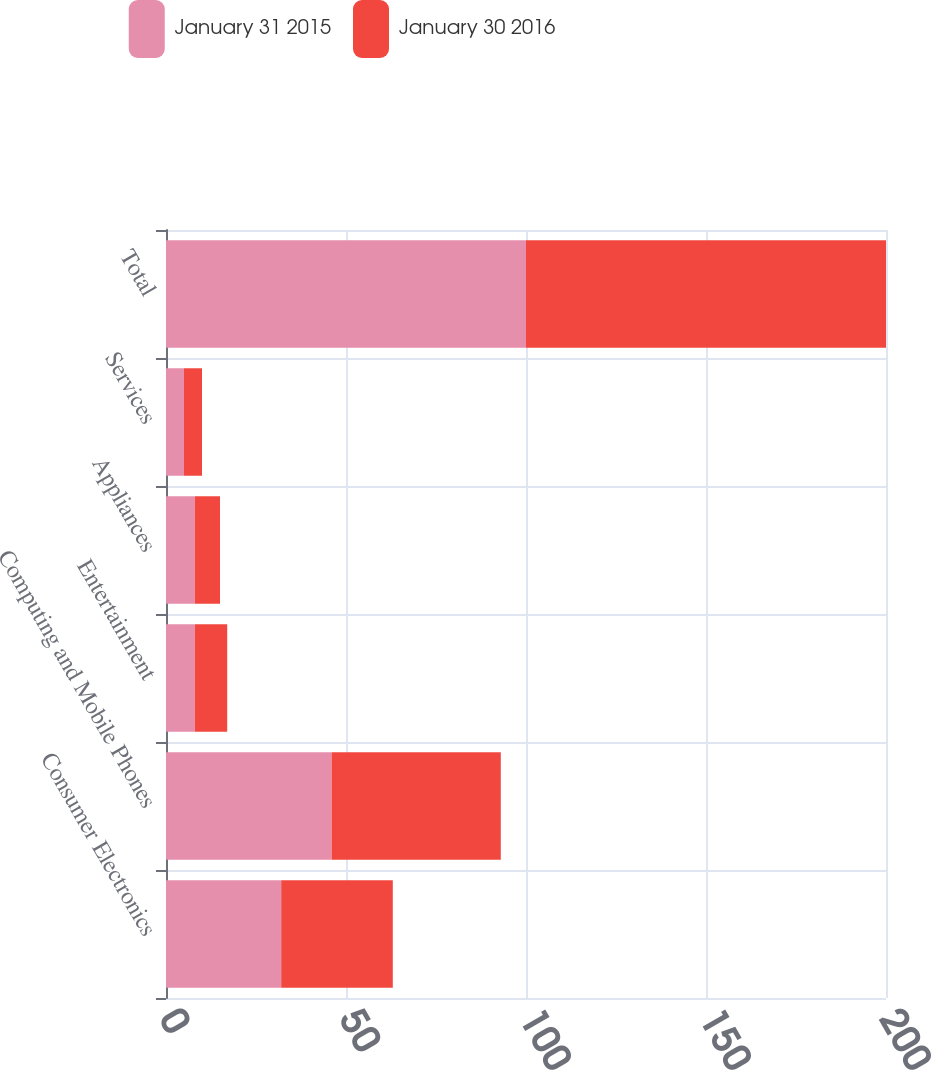Convert chart to OTSL. <chart><loc_0><loc_0><loc_500><loc_500><stacked_bar_chart><ecel><fcel>Consumer Electronics<fcel>Computing and Mobile Phones<fcel>Entertainment<fcel>Appliances<fcel>Services<fcel>Total<nl><fcel>January 31 2015<fcel>32<fcel>46<fcel>8<fcel>8<fcel>5<fcel>100<nl><fcel>January 30 2016<fcel>31<fcel>47<fcel>9<fcel>7<fcel>5<fcel>100<nl></chart> 